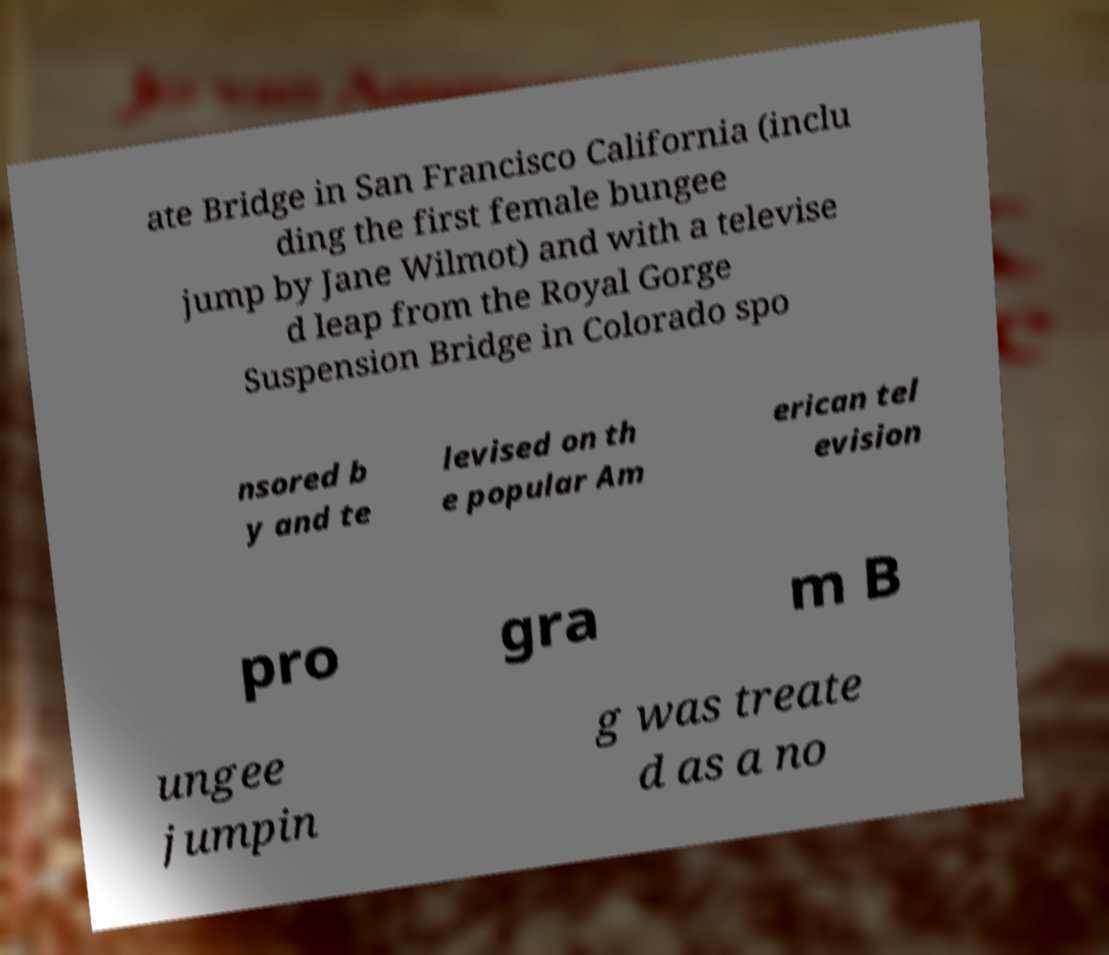Could you extract and type out the text from this image? ate Bridge in San Francisco California (inclu ding the first female bungee jump by Jane Wilmot) and with a televise d leap from the Royal Gorge Suspension Bridge in Colorado spo nsored b y and te levised on th e popular Am erican tel evision pro gra m B ungee jumpin g was treate d as a no 